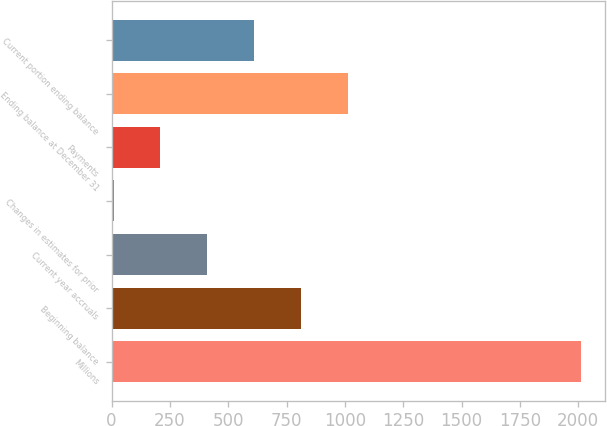Convert chart to OTSL. <chart><loc_0><loc_0><loc_500><loc_500><bar_chart><fcel>Millions<fcel>Beginning balance<fcel>Current year accruals<fcel>Changes in estimates for prior<fcel>Payments<fcel>Ending balance at December 31<fcel>Current portion ending balance<nl><fcel>2014<fcel>811<fcel>410<fcel>9<fcel>209.5<fcel>1011.5<fcel>610.5<nl></chart> 